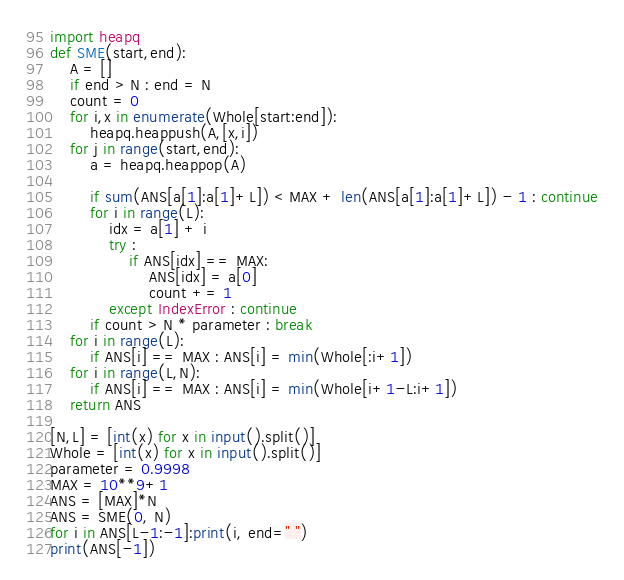Convert code to text. <code><loc_0><loc_0><loc_500><loc_500><_Python_>import heapq
def SME(start,end):
    A = []
    if end > N : end = N
    count = 0
    for i,x in enumerate(Whole[start:end]):
        heapq.heappush(A,[x,i])
    for j in range(start,end):
        a = heapq.heappop(A)
        
        if sum(ANS[a[1]:a[1]+L]) < MAX + len(ANS[a[1]:a[1]+L]) - 1 : continue
        for i in range(L):
            idx = a[1] + i
            try :
                if ANS[idx] == MAX:
                    ANS[idx] = a[0]
                    count += 1
            except IndexError : continue
        if count > N * parameter : break
    for i in range(L):
        if ANS[i] == MAX : ANS[i] = min(Whole[:i+1])
    for i in range(L,N):
        if ANS[i] == MAX : ANS[i] = min(Whole[i+1-L:i+1])
    return ANS

[N,L] = [int(x) for x in input().split()]
Whole = [int(x) for x in input().split()]
parameter = 0.9998
MAX = 10**9+1
ANS = [MAX]*N
ANS = SME(0, N)
for i in ANS[L-1:-1]:print(i, end=" ")
print(ANS[-1])</code> 